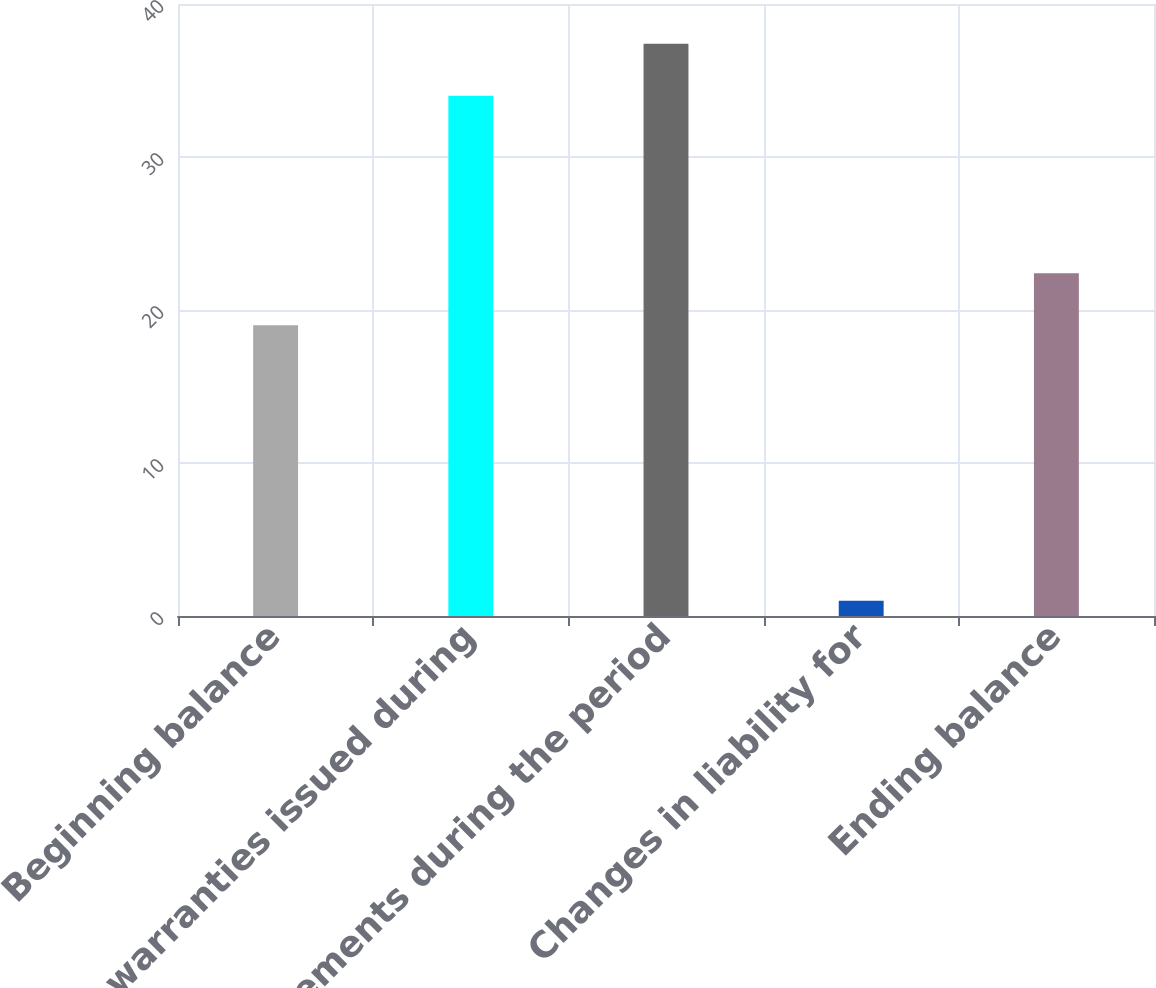<chart> <loc_0><loc_0><loc_500><loc_500><bar_chart><fcel>Beginning balance<fcel>New warranties issued during<fcel>Settlements during the period<fcel>Changes in liability for<fcel>Ending balance<nl><fcel>19<fcel>34<fcel>37.4<fcel>1<fcel>22.4<nl></chart> 